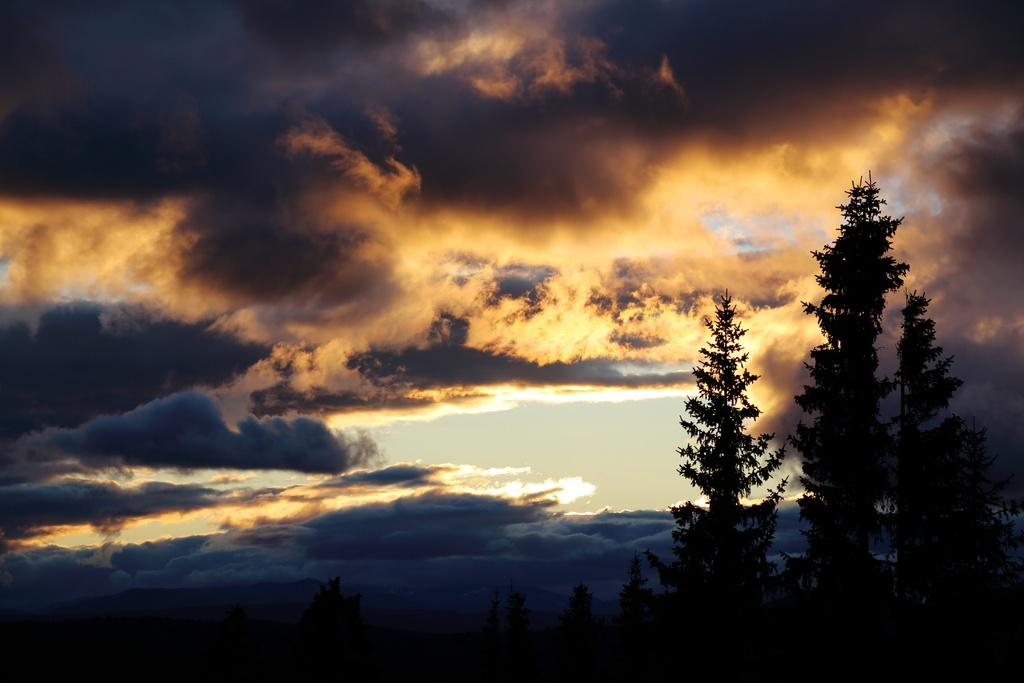What type of vegetation is in the foreground of the image? There are trees in the foreground of the image. What part of the natural environment is visible in the image? The sky is visible in the image. Can you describe the clouds in the sky? There is at least one cloud in the sky. What type of wire can be seen connecting the trees in the image? There is no wire connecting the trees in the image; only the trees and the sky are visible. What type of fruit can be seen growing on the trees in the image? There is no fruit visible on the trees in the image; only the trees and the sky are visible. 